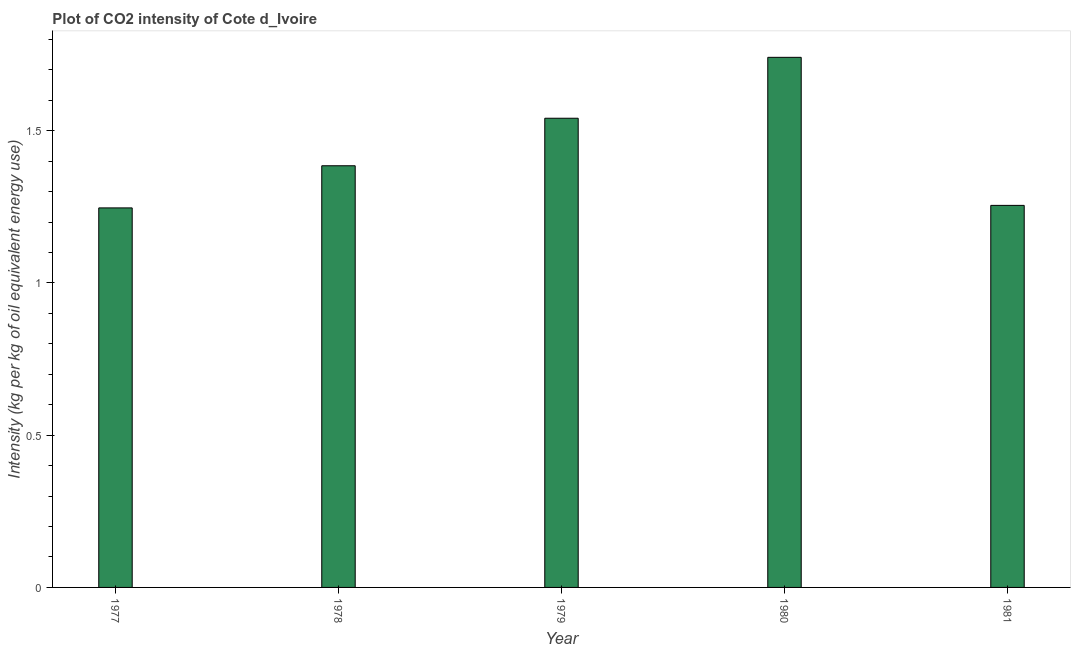Does the graph contain any zero values?
Give a very brief answer. No. What is the title of the graph?
Offer a very short reply. Plot of CO2 intensity of Cote d_Ivoire. What is the label or title of the Y-axis?
Keep it short and to the point. Intensity (kg per kg of oil equivalent energy use). What is the co2 intensity in 1980?
Ensure brevity in your answer.  1.74. Across all years, what is the maximum co2 intensity?
Your response must be concise. 1.74. Across all years, what is the minimum co2 intensity?
Give a very brief answer. 1.25. In which year was the co2 intensity maximum?
Provide a succinct answer. 1980. In which year was the co2 intensity minimum?
Ensure brevity in your answer.  1977. What is the sum of the co2 intensity?
Offer a very short reply. 7.17. What is the difference between the co2 intensity in 1978 and 1981?
Your answer should be compact. 0.13. What is the average co2 intensity per year?
Provide a short and direct response. 1.43. What is the median co2 intensity?
Your response must be concise. 1.39. Do a majority of the years between 1979 and 1980 (inclusive) have co2 intensity greater than 0.2 kg?
Your response must be concise. Yes. Is the difference between the co2 intensity in 1979 and 1980 greater than the difference between any two years?
Your answer should be compact. No. What is the difference between the highest and the second highest co2 intensity?
Your answer should be compact. 0.2. Is the sum of the co2 intensity in 1978 and 1979 greater than the maximum co2 intensity across all years?
Provide a succinct answer. Yes. What is the difference between the highest and the lowest co2 intensity?
Provide a succinct answer. 0.49. Are all the bars in the graph horizontal?
Provide a succinct answer. No. Are the values on the major ticks of Y-axis written in scientific E-notation?
Provide a succinct answer. No. What is the Intensity (kg per kg of oil equivalent energy use) of 1977?
Give a very brief answer. 1.25. What is the Intensity (kg per kg of oil equivalent energy use) in 1978?
Provide a short and direct response. 1.39. What is the Intensity (kg per kg of oil equivalent energy use) of 1979?
Provide a short and direct response. 1.54. What is the Intensity (kg per kg of oil equivalent energy use) of 1980?
Your answer should be compact. 1.74. What is the Intensity (kg per kg of oil equivalent energy use) of 1981?
Your answer should be compact. 1.25. What is the difference between the Intensity (kg per kg of oil equivalent energy use) in 1977 and 1978?
Offer a very short reply. -0.14. What is the difference between the Intensity (kg per kg of oil equivalent energy use) in 1977 and 1979?
Give a very brief answer. -0.29. What is the difference between the Intensity (kg per kg of oil equivalent energy use) in 1977 and 1980?
Give a very brief answer. -0.49. What is the difference between the Intensity (kg per kg of oil equivalent energy use) in 1977 and 1981?
Your answer should be very brief. -0.01. What is the difference between the Intensity (kg per kg of oil equivalent energy use) in 1978 and 1979?
Give a very brief answer. -0.16. What is the difference between the Intensity (kg per kg of oil equivalent energy use) in 1978 and 1980?
Make the answer very short. -0.36. What is the difference between the Intensity (kg per kg of oil equivalent energy use) in 1978 and 1981?
Provide a short and direct response. 0.13. What is the difference between the Intensity (kg per kg of oil equivalent energy use) in 1979 and 1980?
Provide a short and direct response. -0.2. What is the difference between the Intensity (kg per kg of oil equivalent energy use) in 1979 and 1981?
Your answer should be compact. 0.29. What is the difference between the Intensity (kg per kg of oil equivalent energy use) in 1980 and 1981?
Keep it short and to the point. 0.49. What is the ratio of the Intensity (kg per kg of oil equivalent energy use) in 1977 to that in 1978?
Offer a very short reply. 0.9. What is the ratio of the Intensity (kg per kg of oil equivalent energy use) in 1977 to that in 1979?
Your response must be concise. 0.81. What is the ratio of the Intensity (kg per kg of oil equivalent energy use) in 1977 to that in 1980?
Provide a short and direct response. 0.72. What is the ratio of the Intensity (kg per kg of oil equivalent energy use) in 1978 to that in 1979?
Provide a short and direct response. 0.9. What is the ratio of the Intensity (kg per kg of oil equivalent energy use) in 1978 to that in 1980?
Offer a terse response. 0.8. What is the ratio of the Intensity (kg per kg of oil equivalent energy use) in 1978 to that in 1981?
Keep it short and to the point. 1.1. What is the ratio of the Intensity (kg per kg of oil equivalent energy use) in 1979 to that in 1980?
Offer a very short reply. 0.89. What is the ratio of the Intensity (kg per kg of oil equivalent energy use) in 1979 to that in 1981?
Ensure brevity in your answer.  1.23. What is the ratio of the Intensity (kg per kg of oil equivalent energy use) in 1980 to that in 1981?
Your answer should be compact. 1.39. 